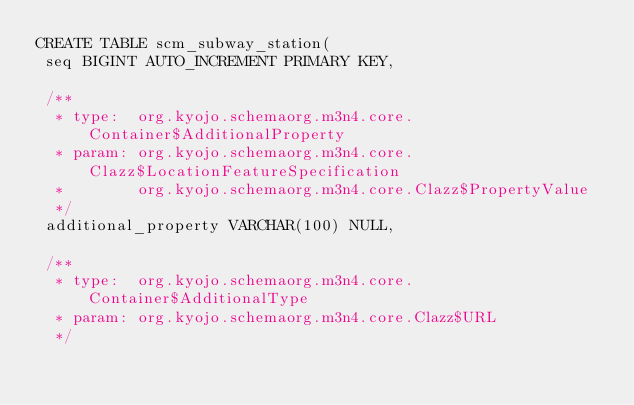<code> <loc_0><loc_0><loc_500><loc_500><_SQL_>CREATE TABLE scm_subway_station(
 seq BIGINT AUTO_INCREMENT PRIMARY KEY,

 /**
  * type:  org.kyojo.schemaorg.m3n4.core.Container$AdditionalProperty
  * param: org.kyojo.schemaorg.m3n4.core.Clazz$LocationFeatureSpecification
  *        org.kyojo.schemaorg.m3n4.core.Clazz$PropertyValue
  */
 additional_property VARCHAR(100) NULL,

 /**
  * type:  org.kyojo.schemaorg.m3n4.core.Container$AdditionalType
  * param: org.kyojo.schemaorg.m3n4.core.Clazz$URL
  */</code> 